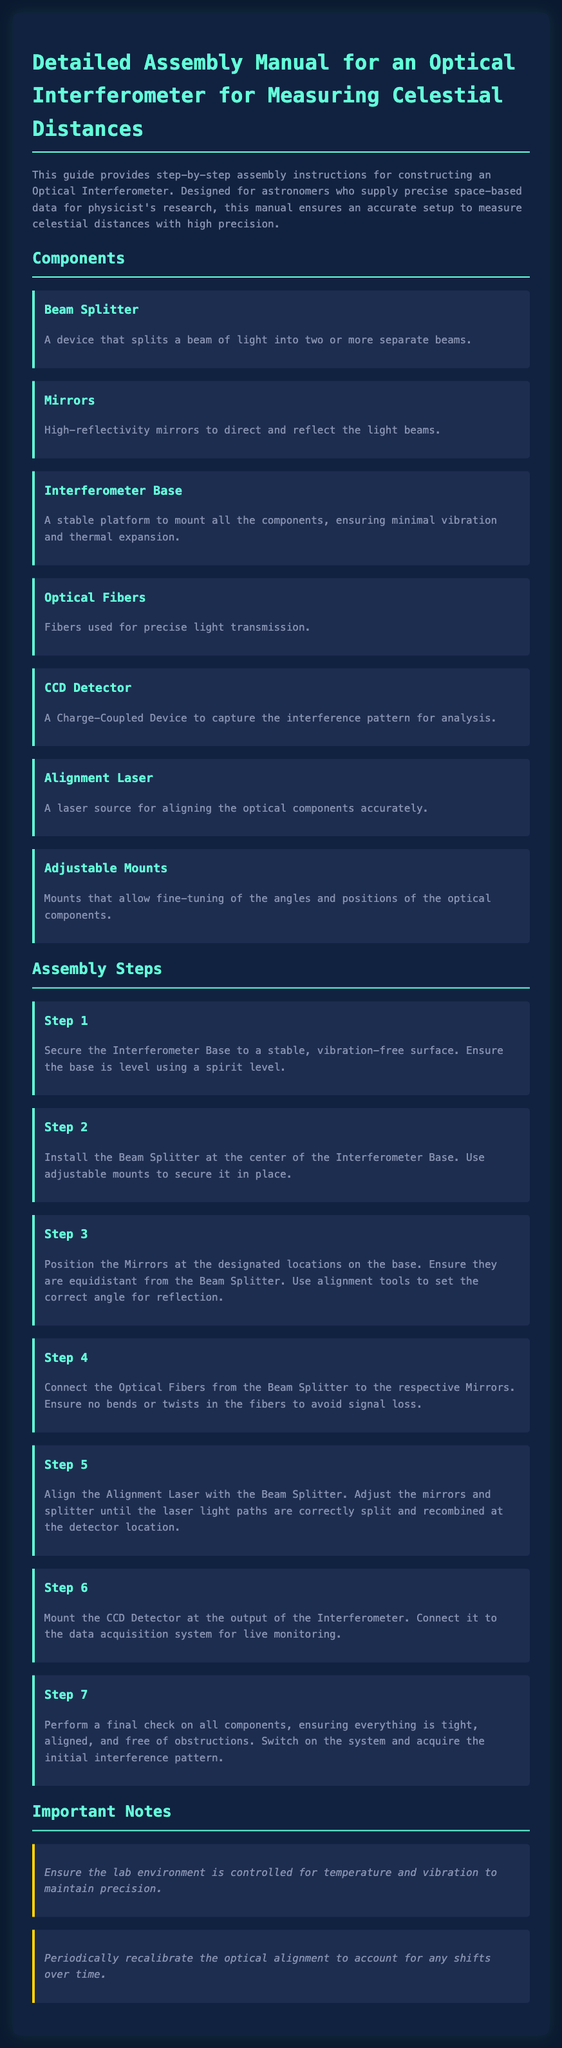What is the main purpose of this manual? The manual provides step-by-step assembly instructions for constructing an Optical Interferometer, ensuring an accurate setup to measure celestial distances.
Answer: Measuring celestial distances How many components are listed in the assembly manual? The manual lists seven components necessary for assembly.
Answer: Seven What is the function of the Beam Splitter? The Beam Splitter is a device that splits a beam of light into two or more separate beams.
Answer: Splitting light beams In which step is the CCD Detector installed? The CCD Detector is installed in Step 6.
Answer: Step 6 What is emphasized in the Important Notes section regarding the lab environment? The lab environment must be controlled for temperature and vibration to maintain precision.
Answer: Environment control Why is it important to periodically recalibrate the optical alignment? To account for any shifts over time in the optical setup.
Answer: Shifts over time What component is described as ensuring minimal vibration? The Interferometer Base is described as a stable platform ensuring minimal vibration and thermal expansion.
Answer: Interferometer Base What tool is suggested for securing the Beam Splitter in place? Adjustable mounts are suggested for securing the Beam Splitter.
Answer: Adjustable mounts 